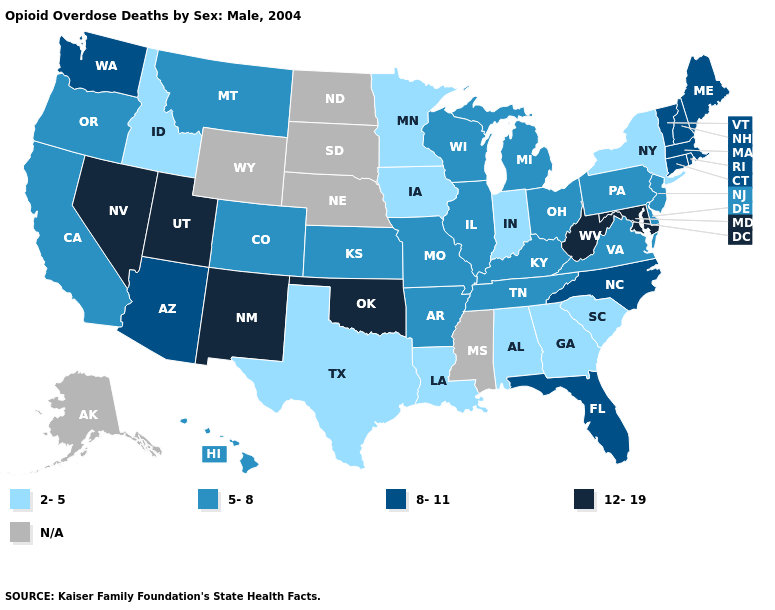What is the highest value in states that border Nebraska?
Give a very brief answer. 5-8. Does Georgia have the lowest value in the USA?
Short answer required. Yes. Name the states that have a value in the range 12-19?
Keep it brief. Maryland, Nevada, New Mexico, Oklahoma, Utah, West Virginia. Does the first symbol in the legend represent the smallest category?
Answer briefly. Yes. Name the states that have a value in the range 8-11?
Be succinct. Arizona, Connecticut, Florida, Maine, Massachusetts, New Hampshire, North Carolina, Rhode Island, Vermont, Washington. Does the first symbol in the legend represent the smallest category?
Be succinct. Yes. What is the value of North Carolina?
Quick response, please. 8-11. Name the states that have a value in the range 12-19?
Answer briefly. Maryland, Nevada, New Mexico, Oklahoma, Utah, West Virginia. Which states have the highest value in the USA?
Write a very short answer. Maryland, Nevada, New Mexico, Oklahoma, Utah, West Virginia. What is the value of New Hampshire?
Be succinct. 8-11. Name the states that have a value in the range N/A?
Be succinct. Alaska, Mississippi, Nebraska, North Dakota, South Dakota, Wyoming. What is the value of Delaware?
Short answer required. 5-8. Which states have the lowest value in the USA?
Short answer required. Alabama, Georgia, Idaho, Indiana, Iowa, Louisiana, Minnesota, New York, South Carolina, Texas. What is the highest value in states that border West Virginia?
Answer briefly. 12-19. 